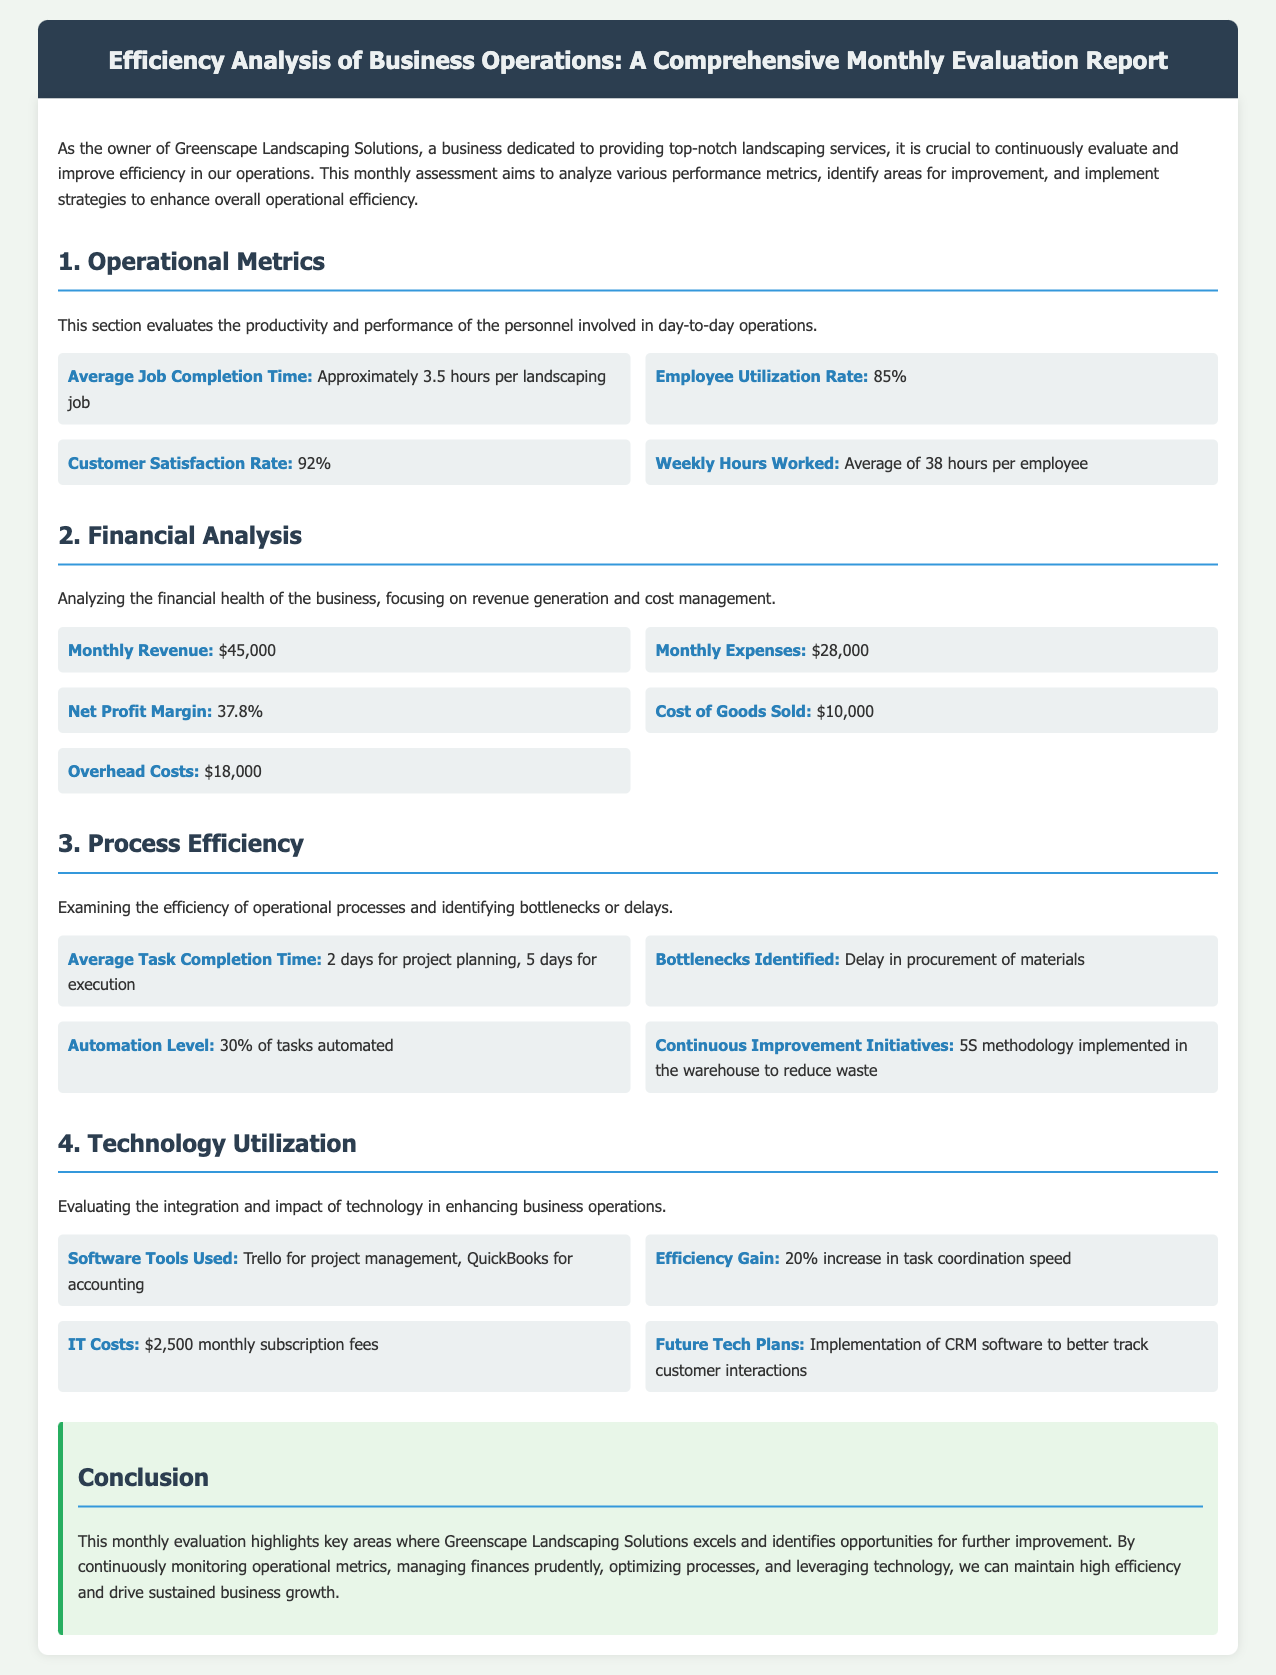what is the average job completion time? The average job completion time for landscaping jobs is mentioned as approximately 3.5 hours.
Answer: approximately 3.5 hours what is the employee utilization rate? The employee utilization rate is specified in the document as 85%.
Answer: 85% what is the monthly revenue? The monthly revenue figure is given as $45,000.
Answer: $45,000 what are the identified bottlenecks? The document highlights that the identified bottlenecks are delays in procurement of materials.
Answer: Delay in procurement of materials what percentage of tasks are automated? The automation level of tasks is stated as 30%.
Answer: 30% what are the software tools used? The software tools that are being utilized include Trello for project management and QuickBooks for accounting.
Answer: Trello for project management, QuickBooks for accounting how much are the IT costs? The monthly subscription fees for IT costs are mentioned as $2,500.
Answer: $2,500 what is the net profit margin? The net profit margin is identified to be 37.8%.
Answer: 37.8% which continuous improvement initiative is implemented? The document notes the implementation of the 5S methodology in the warehouse to reduce waste.
Answer: 5S methodology 